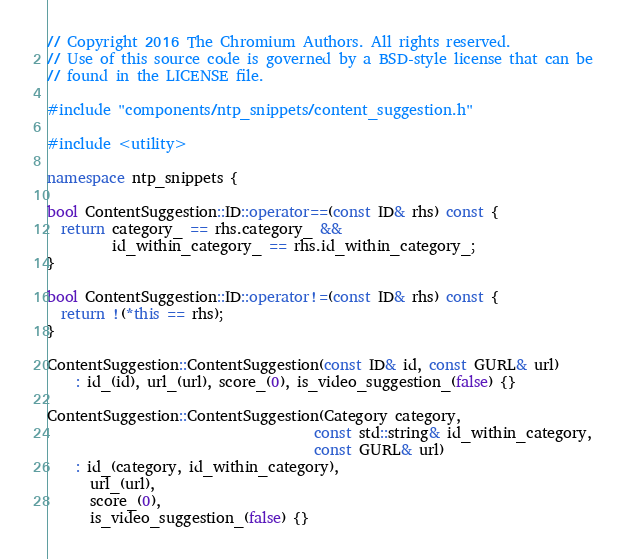Convert code to text. <code><loc_0><loc_0><loc_500><loc_500><_C++_>// Copyright 2016 The Chromium Authors. All rights reserved.
// Use of this source code is governed by a BSD-style license that can be
// found in the LICENSE file.

#include "components/ntp_snippets/content_suggestion.h"

#include <utility>

namespace ntp_snippets {

bool ContentSuggestion::ID::operator==(const ID& rhs) const {
  return category_ == rhs.category_ &&
         id_within_category_ == rhs.id_within_category_;
}

bool ContentSuggestion::ID::operator!=(const ID& rhs) const {
  return !(*this == rhs);
}

ContentSuggestion::ContentSuggestion(const ID& id, const GURL& url)
    : id_(id), url_(url), score_(0), is_video_suggestion_(false) {}

ContentSuggestion::ContentSuggestion(Category category,
                                     const std::string& id_within_category,
                                     const GURL& url)
    : id_(category, id_within_category),
      url_(url),
      score_(0),
      is_video_suggestion_(false) {}
</code> 